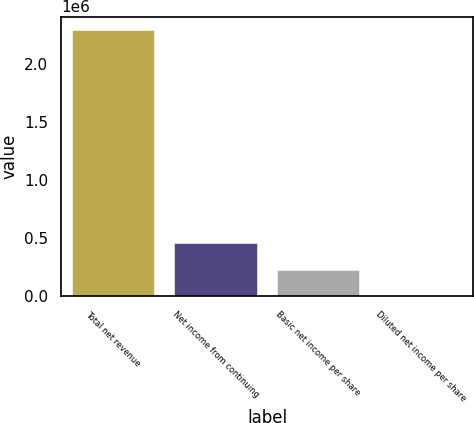Convert chart to OTSL. <chart><loc_0><loc_0><loc_500><loc_500><bar_chart><fcel>Total net revenue<fcel>Net income from continuing<fcel>Basic net income per share<fcel>Diluted net income per share<nl><fcel>2.29301e+06<fcel>458603<fcel>229302<fcel>1.06<nl></chart> 